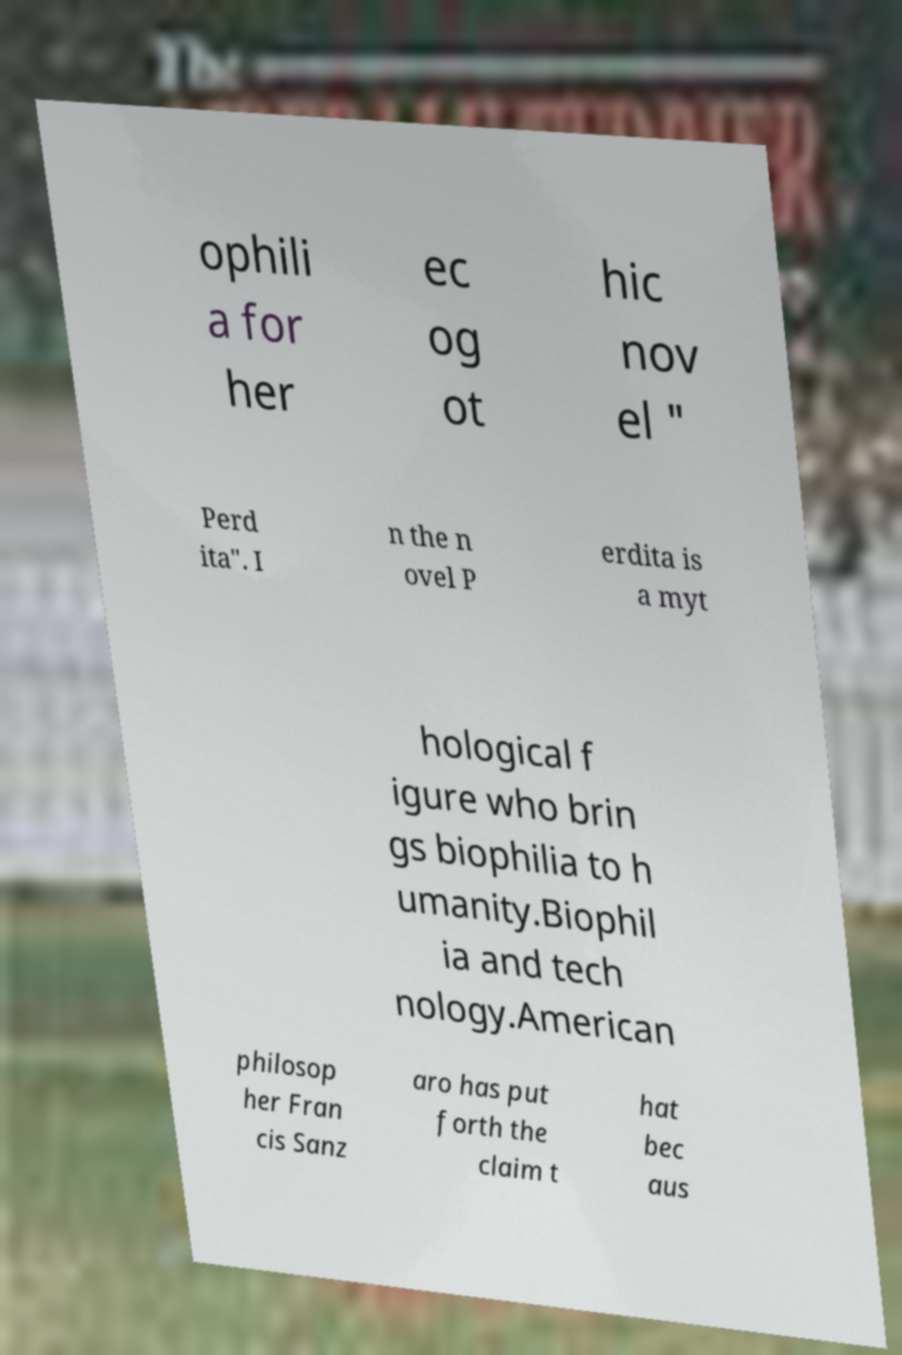Please identify and transcribe the text found in this image. ophili a for her ec og ot hic nov el " Perd ita". I n the n ovel P erdita is a myt hological f igure who brin gs biophilia to h umanity.Biophil ia and tech nology.American philosop her Fran cis Sanz aro has put forth the claim t hat bec aus 